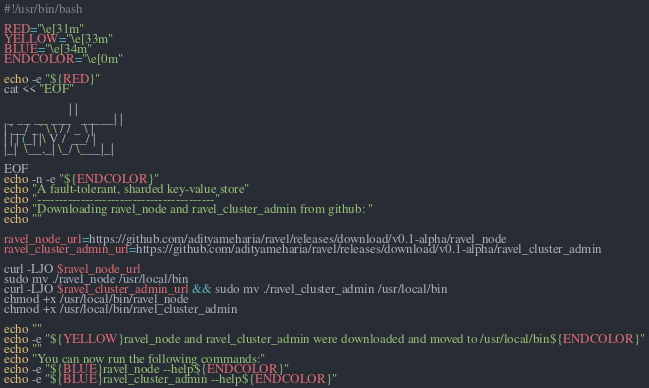Convert code to text. <code><loc_0><loc_0><loc_500><loc_500><_Bash_>#!/usr/bin/bash

RED="\e[31m"
YELLOW="\e[33m"
BLUE="\e[34m"
ENDCOLOR="\e[0m"

echo -e "${RED}"
cat << "EOF"

                    | |
 _ __ __ ___   _____| |
| '__/ _` \ \ / / _ \ |
| | | (_| |\ V /  __/ |
|_|  \__,_| \_/ \___|_|
             
EOF
echo -n -e "${ENDCOLOR}"
echo "A fault-tolerant, sharded key-value store"
echo "-----------------------------------------"
echo "Downloading ravel_node and ravel_cluster_admin from github: "
echo ""

ravel_node_url=https://github.com/adityameharia/ravel/releases/download/v0.1-alpha/ravel_node
ravel_cluster_admin_url=https://github.com/adityameharia/ravel/releases/download/v0.1-alpha/ravel_cluster_admin

curl -LJO $ravel_node_url
sudo mv ./ravel_node /usr/local/bin
curl -LJO $ravel_cluster_admin_url && sudo mv ./ravel_cluster_admin /usr/local/bin
chmod +x /usr/local/bin/ravel_node
chmod +x /usr/local/bin/ravel_cluster_admin

echo ""
echo -e "${YELLOW}ravel_node and ravel_cluster_admin were downloaded and moved to /usr/local/bin${ENDCOLOR}"
echo ""
echo "You can now run the following commands:"
echo -e "${BLUE}ravel_node --help${ENDCOLOR}"
echo -e "${BLUE}ravel_cluster_admin --help${ENDCOLOR}"</code> 